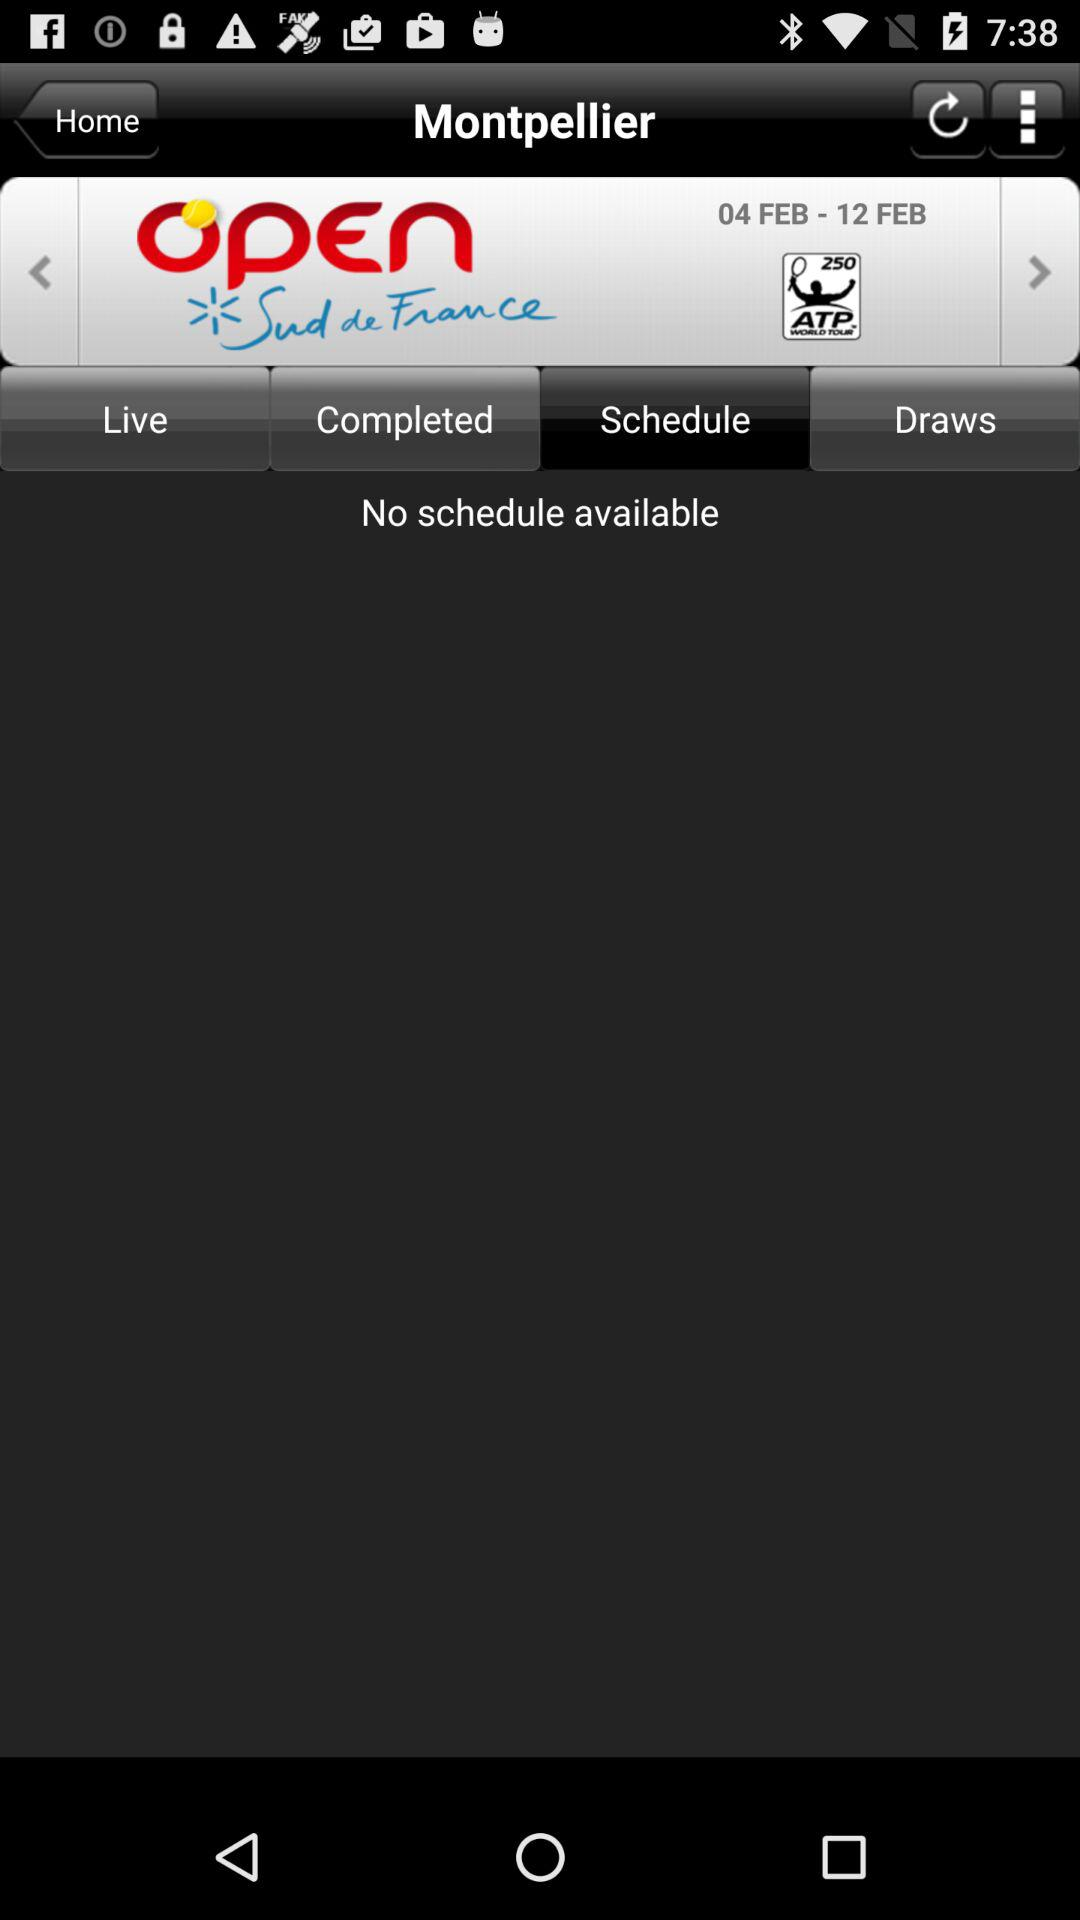Is there any schedule available? There is no schedule available. 